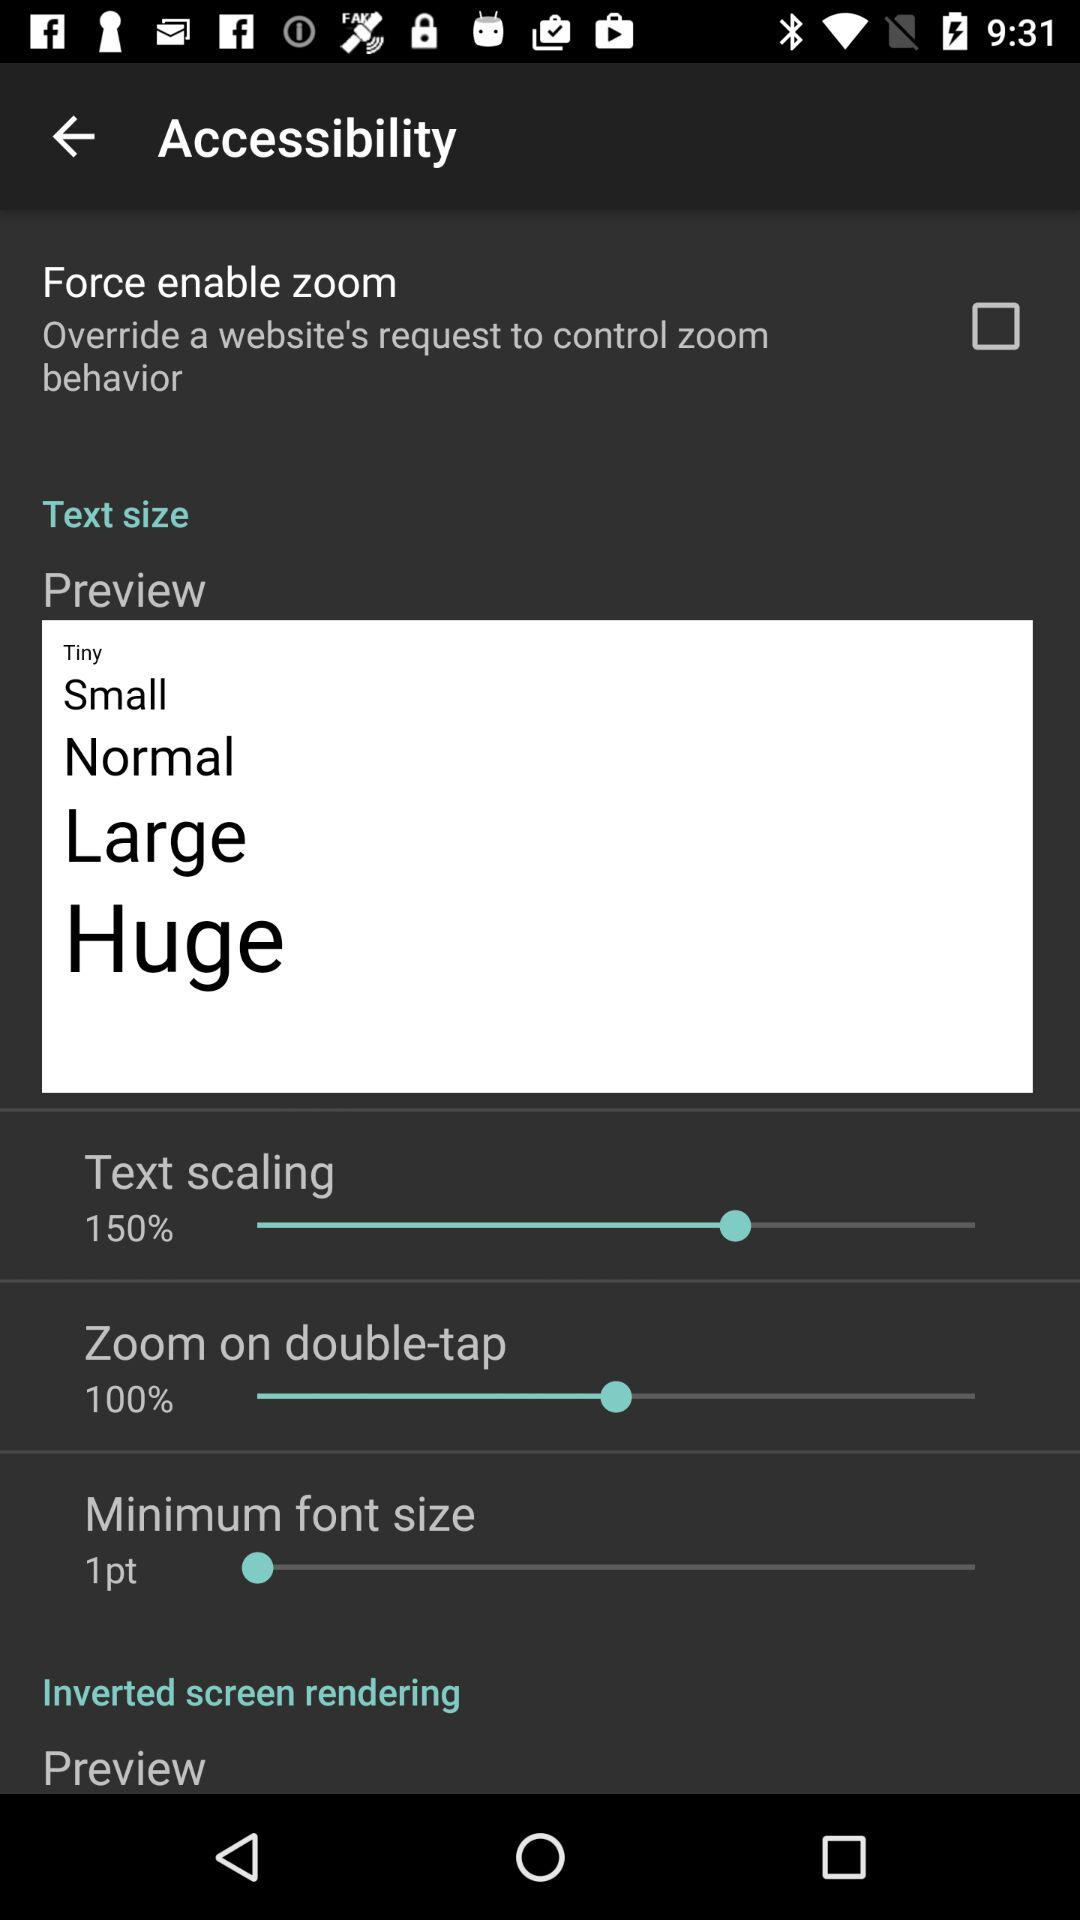What are the different text sizes available on the screen? The different text sizes are tiny, small, normal, large and huge. 